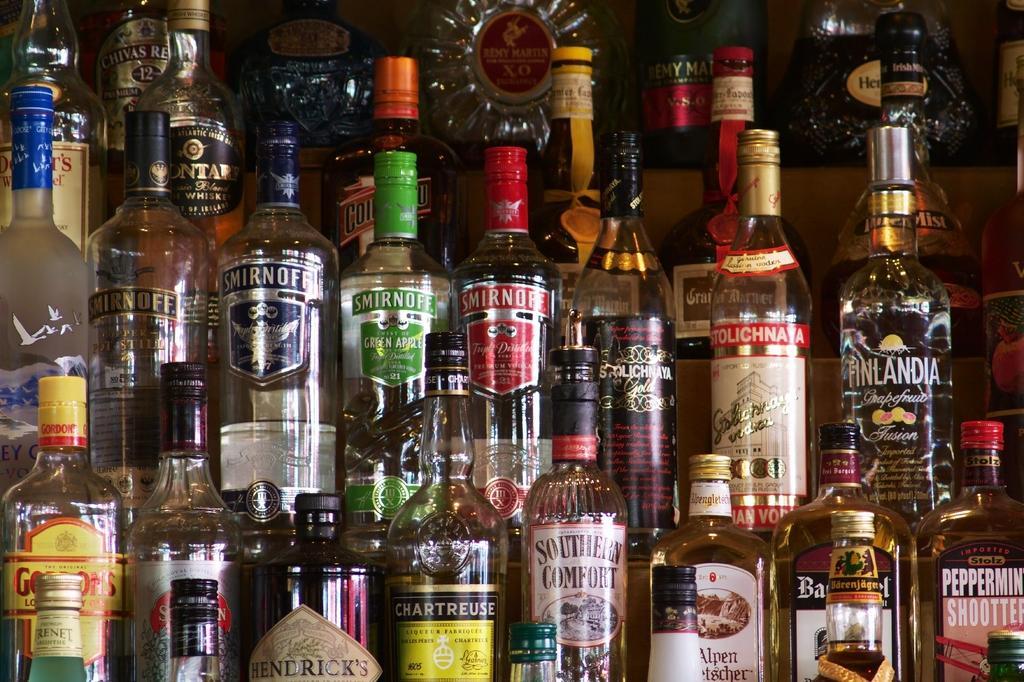How would you summarize this image in a sentence or two? In this image i can see a number of bottles in the shelf. 